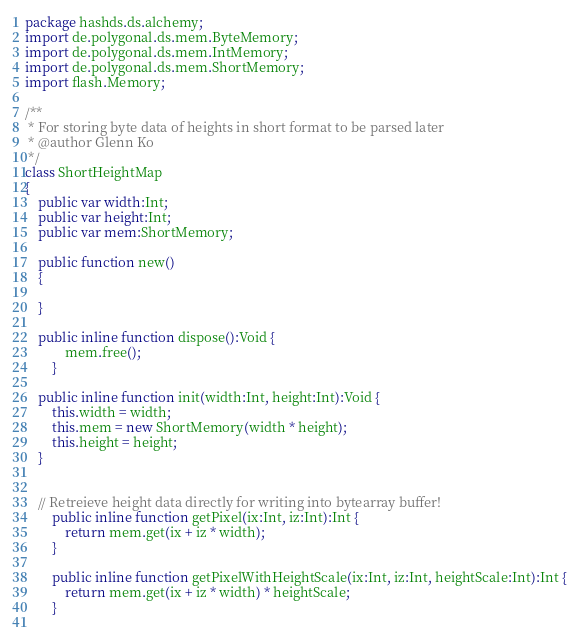<code> <loc_0><loc_0><loc_500><loc_500><_Haxe_>package hashds.ds.alchemy;
import de.polygonal.ds.mem.ByteMemory;
import de.polygonal.ds.mem.IntMemory;
import de.polygonal.ds.mem.ShortMemory;
import flash.Memory;

/**
 * For storing byte data of heights in short format to be parsed later
 * @author Glenn Ko
 */
class ShortHeightMap
{
	public var width:Int;
	public var height:Int;
	public var mem:ShortMemory;

	public function new() 
	{
	
	}
	
	public inline function dispose():Void {
			mem.free();
		}
	
	public inline function init(width:Int, height:Int):Void {
		this.width = width;
		this.mem = new ShortMemory(width * height);
		this.height = height;
	}
	
	
	// Retreieve height data directly for writing into bytearray buffer!
		public inline function getPixel(ix:Int, iz:Int):Int {
			return mem.get(ix + iz * width); 
		}
		
		public inline function getPixelWithHeightScale(ix:Int, iz:Int, heightScale:Int):Int {
			return mem.get(ix + iz * width) * heightScale; 
		}
		</code> 